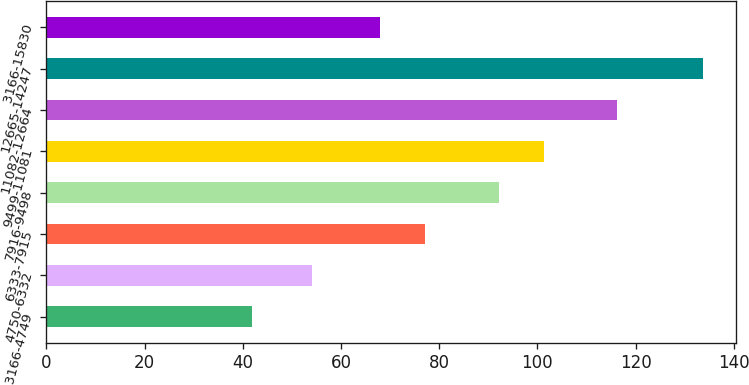<chart> <loc_0><loc_0><loc_500><loc_500><bar_chart><fcel>3166-4749<fcel>4750-6332<fcel>6333-7915<fcel>7916-9498<fcel>9499-11081<fcel>11082-12664<fcel>12665-14247<fcel>3166-15830<nl><fcel>41.82<fcel>54.1<fcel>77.22<fcel>92.24<fcel>101.44<fcel>116.27<fcel>133.77<fcel>68.02<nl></chart> 